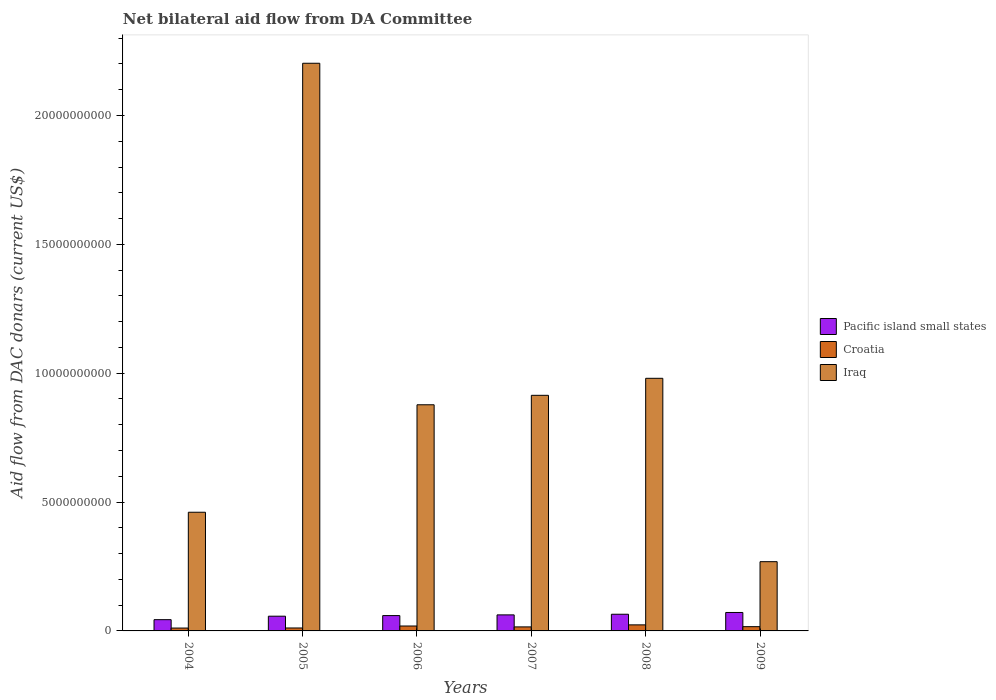How many different coloured bars are there?
Your answer should be compact. 3. How many groups of bars are there?
Give a very brief answer. 6. How many bars are there on the 6th tick from the right?
Offer a very short reply. 3. What is the label of the 4th group of bars from the left?
Offer a terse response. 2007. What is the aid flow in in Pacific island small states in 2005?
Ensure brevity in your answer.  5.71e+08. Across all years, what is the maximum aid flow in in Croatia?
Offer a terse response. 2.35e+08. Across all years, what is the minimum aid flow in in Pacific island small states?
Offer a terse response. 4.37e+08. What is the total aid flow in in Pacific island small states in the graph?
Your answer should be compact. 3.59e+09. What is the difference between the aid flow in in Pacific island small states in 2006 and that in 2007?
Provide a succinct answer. -2.73e+07. What is the difference between the aid flow in in Pacific island small states in 2005 and the aid flow in in Croatia in 2006?
Keep it short and to the point. 3.81e+08. What is the average aid flow in in Croatia per year?
Offer a very short reply. 1.62e+08. In the year 2004, what is the difference between the aid flow in in Iraq and aid flow in in Pacific island small states?
Provide a succinct answer. 4.17e+09. What is the ratio of the aid flow in in Croatia in 2006 to that in 2008?
Keep it short and to the point. 0.81. Is the aid flow in in Croatia in 2004 less than that in 2008?
Provide a short and direct response. Yes. Is the difference between the aid flow in in Iraq in 2004 and 2006 greater than the difference between the aid flow in in Pacific island small states in 2004 and 2006?
Offer a very short reply. No. What is the difference between the highest and the second highest aid flow in in Croatia?
Your response must be concise. 4.46e+07. What is the difference between the highest and the lowest aid flow in in Iraq?
Keep it short and to the point. 1.93e+1. What does the 2nd bar from the left in 2005 represents?
Your answer should be very brief. Croatia. What does the 3rd bar from the right in 2005 represents?
Offer a very short reply. Pacific island small states. Is it the case that in every year, the sum of the aid flow in in Croatia and aid flow in in Iraq is greater than the aid flow in in Pacific island small states?
Offer a terse response. Yes. How many bars are there?
Provide a short and direct response. 18. How many years are there in the graph?
Your response must be concise. 6. Does the graph contain grids?
Your response must be concise. No. Where does the legend appear in the graph?
Provide a succinct answer. Center right. How many legend labels are there?
Give a very brief answer. 3. How are the legend labels stacked?
Ensure brevity in your answer.  Vertical. What is the title of the graph?
Give a very brief answer. Net bilateral aid flow from DA Committee. Does "Tuvalu" appear as one of the legend labels in the graph?
Give a very brief answer. No. What is the label or title of the X-axis?
Make the answer very short. Years. What is the label or title of the Y-axis?
Offer a very short reply. Aid flow from DAC donars (current US$). What is the Aid flow from DAC donars (current US$) of Pacific island small states in 2004?
Provide a succinct answer. 4.37e+08. What is the Aid flow from DAC donars (current US$) in Croatia in 2004?
Your answer should be compact. 1.12e+08. What is the Aid flow from DAC donars (current US$) in Iraq in 2004?
Give a very brief answer. 4.61e+09. What is the Aid flow from DAC donars (current US$) of Pacific island small states in 2005?
Offer a terse response. 5.71e+08. What is the Aid flow from DAC donars (current US$) in Croatia in 2005?
Provide a short and direct response. 1.14e+08. What is the Aid flow from DAC donars (current US$) in Iraq in 2005?
Your answer should be very brief. 2.20e+1. What is the Aid flow from DAC donars (current US$) of Pacific island small states in 2006?
Offer a very short reply. 5.95e+08. What is the Aid flow from DAC donars (current US$) of Croatia in 2006?
Your answer should be compact. 1.90e+08. What is the Aid flow from DAC donars (current US$) in Iraq in 2006?
Make the answer very short. 8.78e+09. What is the Aid flow from DAC donars (current US$) in Pacific island small states in 2007?
Give a very brief answer. 6.22e+08. What is the Aid flow from DAC donars (current US$) in Croatia in 2007?
Give a very brief answer. 1.56e+08. What is the Aid flow from DAC donars (current US$) of Iraq in 2007?
Make the answer very short. 9.14e+09. What is the Aid flow from DAC donars (current US$) in Pacific island small states in 2008?
Offer a terse response. 6.47e+08. What is the Aid flow from DAC donars (current US$) of Croatia in 2008?
Provide a short and direct response. 2.35e+08. What is the Aid flow from DAC donars (current US$) in Iraq in 2008?
Give a very brief answer. 9.80e+09. What is the Aid flow from DAC donars (current US$) in Pacific island small states in 2009?
Ensure brevity in your answer.  7.16e+08. What is the Aid flow from DAC donars (current US$) in Croatia in 2009?
Keep it short and to the point. 1.65e+08. What is the Aid flow from DAC donars (current US$) in Iraq in 2009?
Offer a very short reply. 2.69e+09. Across all years, what is the maximum Aid flow from DAC donars (current US$) of Pacific island small states?
Ensure brevity in your answer.  7.16e+08. Across all years, what is the maximum Aid flow from DAC donars (current US$) in Croatia?
Ensure brevity in your answer.  2.35e+08. Across all years, what is the maximum Aid flow from DAC donars (current US$) in Iraq?
Your answer should be very brief. 2.20e+1. Across all years, what is the minimum Aid flow from DAC donars (current US$) in Pacific island small states?
Your answer should be very brief. 4.37e+08. Across all years, what is the minimum Aid flow from DAC donars (current US$) in Croatia?
Give a very brief answer. 1.12e+08. Across all years, what is the minimum Aid flow from DAC donars (current US$) of Iraq?
Provide a succinct answer. 2.69e+09. What is the total Aid flow from DAC donars (current US$) of Pacific island small states in the graph?
Your answer should be very brief. 3.59e+09. What is the total Aid flow from DAC donars (current US$) in Croatia in the graph?
Your answer should be very brief. 9.72e+08. What is the total Aid flow from DAC donars (current US$) of Iraq in the graph?
Your answer should be very brief. 5.70e+1. What is the difference between the Aid flow from DAC donars (current US$) in Pacific island small states in 2004 and that in 2005?
Your answer should be very brief. -1.34e+08. What is the difference between the Aid flow from DAC donars (current US$) of Croatia in 2004 and that in 2005?
Keep it short and to the point. -2.59e+06. What is the difference between the Aid flow from DAC donars (current US$) in Iraq in 2004 and that in 2005?
Your answer should be very brief. -1.74e+1. What is the difference between the Aid flow from DAC donars (current US$) in Pacific island small states in 2004 and that in 2006?
Your answer should be very brief. -1.58e+08. What is the difference between the Aid flow from DAC donars (current US$) of Croatia in 2004 and that in 2006?
Make the answer very short. -7.90e+07. What is the difference between the Aid flow from DAC donars (current US$) in Iraq in 2004 and that in 2006?
Provide a succinct answer. -4.17e+09. What is the difference between the Aid flow from DAC donars (current US$) in Pacific island small states in 2004 and that in 2007?
Make the answer very short. -1.85e+08. What is the difference between the Aid flow from DAC donars (current US$) in Croatia in 2004 and that in 2007?
Your answer should be very brief. -4.49e+07. What is the difference between the Aid flow from DAC donars (current US$) of Iraq in 2004 and that in 2007?
Your response must be concise. -4.54e+09. What is the difference between the Aid flow from DAC donars (current US$) of Pacific island small states in 2004 and that in 2008?
Your answer should be compact. -2.10e+08. What is the difference between the Aid flow from DAC donars (current US$) of Croatia in 2004 and that in 2008?
Offer a very short reply. -1.24e+08. What is the difference between the Aid flow from DAC donars (current US$) of Iraq in 2004 and that in 2008?
Give a very brief answer. -5.20e+09. What is the difference between the Aid flow from DAC donars (current US$) of Pacific island small states in 2004 and that in 2009?
Your answer should be very brief. -2.79e+08. What is the difference between the Aid flow from DAC donars (current US$) of Croatia in 2004 and that in 2009?
Keep it short and to the point. -5.34e+07. What is the difference between the Aid flow from DAC donars (current US$) in Iraq in 2004 and that in 2009?
Make the answer very short. 1.92e+09. What is the difference between the Aid flow from DAC donars (current US$) of Pacific island small states in 2005 and that in 2006?
Offer a very short reply. -2.35e+07. What is the difference between the Aid flow from DAC donars (current US$) in Croatia in 2005 and that in 2006?
Give a very brief answer. -7.64e+07. What is the difference between the Aid flow from DAC donars (current US$) in Iraq in 2005 and that in 2006?
Keep it short and to the point. 1.33e+1. What is the difference between the Aid flow from DAC donars (current US$) in Pacific island small states in 2005 and that in 2007?
Give a very brief answer. -5.08e+07. What is the difference between the Aid flow from DAC donars (current US$) of Croatia in 2005 and that in 2007?
Provide a short and direct response. -4.23e+07. What is the difference between the Aid flow from DAC donars (current US$) in Iraq in 2005 and that in 2007?
Provide a short and direct response. 1.29e+1. What is the difference between the Aid flow from DAC donars (current US$) in Pacific island small states in 2005 and that in 2008?
Offer a very short reply. -7.57e+07. What is the difference between the Aid flow from DAC donars (current US$) of Croatia in 2005 and that in 2008?
Provide a succinct answer. -1.21e+08. What is the difference between the Aid flow from DAC donars (current US$) of Iraq in 2005 and that in 2008?
Offer a terse response. 1.22e+1. What is the difference between the Aid flow from DAC donars (current US$) of Pacific island small states in 2005 and that in 2009?
Provide a short and direct response. -1.45e+08. What is the difference between the Aid flow from DAC donars (current US$) in Croatia in 2005 and that in 2009?
Give a very brief answer. -5.08e+07. What is the difference between the Aid flow from DAC donars (current US$) in Iraq in 2005 and that in 2009?
Your response must be concise. 1.93e+1. What is the difference between the Aid flow from DAC donars (current US$) of Pacific island small states in 2006 and that in 2007?
Your answer should be very brief. -2.73e+07. What is the difference between the Aid flow from DAC donars (current US$) in Croatia in 2006 and that in 2007?
Your answer should be very brief. 3.41e+07. What is the difference between the Aid flow from DAC donars (current US$) of Iraq in 2006 and that in 2007?
Give a very brief answer. -3.67e+08. What is the difference between the Aid flow from DAC donars (current US$) of Pacific island small states in 2006 and that in 2008?
Keep it short and to the point. -5.22e+07. What is the difference between the Aid flow from DAC donars (current US$) of Croatia in 2006 and that in 2008?
Provide a succinct answer. -4.46e+07. What is the difference between the Aid flow from DAC donars (current US$) of Iraq in 2006 and that in 2008?
Offer a terse response. -1.03e+09. What is the difference between the Aid flow from DAC donars (current US$) of Pacific island small states in 2006 and that in 2009?
Provide a short and direct response. -1.21e+08. What is the difference between the Aid flow from DAC donars (current US$) of Croatia in 2006 and that in 2009?
Keep it short and to the point. 2.56e+07. What is the difference between the Aid flow from DAC donars (current US$) of Iraq in 2006 and that in 2009?
Provide a succinct answer. 6.09e+09. What is the difference between the Aid flow from DAC donars (current US$) in Pacific island small states in 2007 and that in 2008?
Your response must be concise. -2.49e+07. What is the difference between the Aid flow from DAC donars (current US$) in Croatia in 2007 and that in 2008?
Your response must be concise. -7.87e+07. What is the difference between the Aid flow from DAC donars (current US$) in Iraq in 2007 and that in 2008?
Make the answer very short. -6.60e+08. What is the difference between the Aid flow from DAC donars (current US$) in Pacific island small states in 2007 and that in 2009?
Provide a succinct answer. -9.38e+07. What is the difference between the Aid flow from DAC donars (current US$) in Croatia in 2007 and that in 2009?
Offer a terse response. -8.51e+06. What is the difference between the Aid flow from DAC donars (current US$) of Iraq in 2007 and that in 2009?
Ensure brevity in your answer.  6.46e+09. What is the difference between the Aid flow from DAC donars (current US$) in Pacific island small states in 2008 and that in 2009?
Provide a succinct answer. -6.89e+07. What is the difference between the Aid flow from DAC donars (current US$) in Croatia in 2008 and that in 2009?
Provide a succinct answer. 7.02e+07. What is the difference between the Aid flow from DAC donars (current US$) in Iraq in 2008 and that in 2009?
Provide a succinct answer. 7.12e+09. What is the difference between the Aid flow from DAC donars (current US$) in Pacific island small states in 2004 and the Aid flow from DAC donars (current US$) in Croatia in 2005?
Ensure brevity in your answer.  3.23e+08. What is the difference between the Aid flow from DAC donars (current US$) of Pacific island small states in 2004 and the Aid flow from DAC donars (current US$) of Iraq in 2005?
Offer a very short reply. -2.16e+1. What is the difference between the Aid flow from DAC donars (current US$) in Croatia in 2004 and the Aid flow from DAC donars (current US$) in Iraq in 2005?
Provide a succinct answer. -2.19e+1. What is the difference between the Aid flow from DAC donars (current US$) of Pacific island small states in 2004 and the Aid flow from DAC donars (current US$) of Croatia in 2006?
Provide a succinct answer. 2.47e+08. What is the difference between the Aid flow from DAC donars (current US$) in Pacific island small states in 2004 and the Aid flow from DAC donars (current US$) in Iraq in 2006?
Keep it short and to the point. -8.34e+09. What is the difference between the Aid flow from DAC donars (current US$) in Croatia in 2004 and the Aid flow from DAC donars (current US$) in Iraq in 2006?
Ensure brevity in your answer.  -8.66e+09. What is the difference between the Aid flow from DAC donars (current US$) in Pacific island small states in 2004 and the Aid flow from DAC donars (current US$) in Croatia in 2007?
Make the answer very short. 2.81e+08. What is the difference between the Aid flow from DAC donars (current US$) in Pacific island small states in 2004 and the Aid flow from DAC donars (current US$) in Iraq in 2007?
Your answer should be compact. -8.71e+09. What is the difference between the Aid flow from DAC donars (current US$) in Croatia in 2004 and the Aid flow from DAC donars (current US$) in Iraq in 2007?
Your answer should be compact. -9.03e+09. What is the difference between the Aid flow from DAC donars (current US$) of Pacific island small states in 2004 and the Aid flow from DAC donars (current US$) of Croatia in 2008?
Provide a short and direct response. 2.02e+08. What is the difference between the Aid flow from DAC donars (current US$) of Pacific island small states in 2004 and the Aid flow from DAC donars (current US$) of Iraq in 2008?
Your response must be concise. -9.37e+09. What is the difference between the Aid flow from DAC donars (current US$) of Croatia in 2004 and the Aid flow from DAC donars (current US$) of Iraq in 2008?
Ensure brevity in your answer.  -9.69e+09. What is the difference between the Aid flow from DAC donars (current US$) of Pacific island small states in 2004 and the Aid flow from DAC donars (current US$) of Croatia in 2009?
Offer a very short reply. 2.72e+08. What is the difference between the Aid flow from DAC donars (current US$) in Pacific island small states in 2004 and the Aid flow from DAC donars (current US$) in Iraq in 2009?
Keep it short and to the point. -2.25e+09. What is the difference between the Aid flow from DAC donars (current US$) of Croatia in 2004 and the Aid flow from DAC donars (current US$) of Iraq in 2009?
Make the answer very short. -2.58e+09. What is the difference between the Aid flow from DAC donars (current US$) in Pacific island small states in 2005 and the Aid flow from DAC donars (current US$) in Croatia in 2006?
Your answer should be compact. 3.81e+08. What is the difference between the Aid flow from DAC donars (current US$) in Pacific island small states in 2005 and the Aid flow from DAC donars (current US$) in Iraq in 2006?
Offer a terse response. -8.20e+09. What is the difference between the Aid flow from DAC donars (current US$) of Croatia in 2005 and the Aid flow from DAC donars (current US$) of Iraq in 2006?
Your answer should be very brief. -8.66e+09. What is the difference between the Aid flow from DAC donars (current US$) of Pacific island small states in 2005 and the Aid flow from DAC donars (current US$) of Croatia in 2007?
Your answer should be compact. 4.15e+08. What is the difference between the Aid flow from DAC donars (current US$) of Pacific island small states in 2005 and the Aid flow from DAC donars (current US$) of Iraq in 2007?
Keep it short and to the point. -8.57e+09. What is the difference between the Aid flow from DAC donars (current US$) in Croatia in 2005 and the Aid flow from DAC donars (current US$) in Iraq in 2007?
Make the answer very short. -9.03e+09. What is the difference between the Aid flow from DAC donars (current US$) in Pacific island small states in 2005 and the Aid flow from DAC donars (current US$) in Croatia in 2008?
Provide a short and direct response. 3.36e+08. What is the difference between the Aid flow from DAC donars (current US$) of Pacific island small states in 2005 and the Aid flow from DAC donars (current US$) of Iraq in 2008?
Provide a succinct answer. -9.23e+09. What is the difference between the Aid flow from DAC donars (current US$) of Croatia in 2005 and the Aid flow from DAC donars (current US$) of Iraq in 2008?
Ensure brevity in your answer.  -9.69e+09. What is the difference between the Aid flow from DAC donars (current US$) of Pacific island small states in 2005 and the Aid flow from DAC donars (current US$) of Croatia in 2009?
Offer a very short reply. 4.06e+08. What is the difference between the Aid flow from DAC donars (current US$) of Pacific island small states in 2005 and the Aid flow from DAC donars (current US$) of Iraq in 2009?
Offer a terse response. -2.12e+09. What is the difference between the Aid flow from DAC donars (current US$) in Croatia in 2005 and the Aid flow from DAC donars (current US$) in Iraq in 2009?
Provide a succinct answer. -2.57e+09. What is the difference between the Aid flow from DAC donars (current US$) of Pacific island small states in 2006 and the Aid flow from DAC donars (current US$) of Croatia in 2007?
Give a very brief answer. 4.39e+08. What is the difference between the Aid flow from DAC donars (current US$) in Pacific island small states in 2006 and the Aid flow from DAC donars (current US$) in Iraq in 2007?
Make the answer very short. -8.55e+09. What is the difference between the Aid flow from DAC donars (current US$) of Croatia in 2006 and the Aid flow from DAC donars (current US$) of Iraq in 2007?
Give a very brief answer. -8.95e+09. What is the difference between the Aid flow from DAC donars (current US$) in Pacific island small states in 2006 and the Aid flow from DAC donars (current US$) in Croatia in 2008?
Keep it short and to the point. 3.60e+08. What is the difference between the Aid flow from DAC donars (current US$) of Pacific island small states in 2006 and the Aid flow from DAC donars (current US$) of Iraq in 2008?
Give a very brief answer. -9.21e+09. What is the difference between the Aid flow from DAC donars (current US$) in Croatia in 2006 and the Aid flow from DAC donars (current US$) in Iraq in 2008?
Make the answer very short. -9.61e+09. What is the difference between the Aid flow from DAC donars (current US$) in Pacific island small states in 2006 and the Aid flow from DAC donars (current US$) in Croatia in 2009?
Provide a succinct answer. 4.30e+08. What is the difference between the Aid flow from DAC donars (current US$) in Pacific island small states in 2006 and the Aid flow from DAC donars (current US$) in Iraq in 2009?
Make the answer very short. -2.09e+09. What is the difference between the Aid flow from DAC donars (current US$) of Croatia in 2006 and the Aid flow from DAC donars (current US$) of Iraq in 2009?
Your answer should be very brief. -2.50e+09. What is the difference between the Aid flow from DAC donars (current US$) of Pacific island small states in 2007 and the Aid flow from DAC donars (current US$) of Croatia in 2008?
Provide a short and direct response. 3.87e+08. What is the difference between the Aid flow from DAC donars (current US$) in Pacific island small states in 2007 and the Aid flow from DAC donars (current US$) in Iraq in 2008?
Your answer should be compact. -9.18e+09. What is the difference between the Aid flow from DAC donars (current US$) in Croatia in 2007 and the Aid flow from DAC donars (current US$) in Iraq in 2008?
Offer a terse response. -9.65e+09. What is the difference between the Aid flow from DAC donars (current US$) of Pacific island small states in 2007 and the Aid flow from DAC donars (current US$) of Croatia in 2009?
Offer a terse response. 4.57e+08. What is the difference between the Aid flow from DAC donars (current US$) of Pacific island small states in 2007 and the Aid flow from DAC donars (current US$) of Iraq in 2009?
Provide a short and direct response. -2.06e+09. What is the difference between the Aid flow from DAC donars (current US$) of Croatia in 2007 and the Aid flow from DAC donars (current US$) of Iraq in 2009?
Give a very brief answer. -2.53e+09. What is the difference between the Aid flow from DAC donars (current US$) in Pacific island small states in 2008 and the Aid flow from DAC donars (current US$) in Croatia in 2009?
Make the answer very short. 4.82e+08. What is the difference between the Aid flow from DAC donars (current US$) in Pacific island small states in 2008 and the Aid flow from DAC donars (current US$) in Iraq in 2009?
Your response must be concise. -2.04e+09. What is the difference between the Aid flow from DAC donars (current US$) of Croatia in 2008 and the Aid flow from DAC donars (current US$) of Iraq in 2009?
Your answer should be compact. -2.45e+09. What is the average Aid flow from DAC donars (current US$) in Pacific island small states per year?
Provide a succinct answer. 5.98e+08. What is the average Aid flow from DAC donars (current US$) in Croatia per year?
Keep it short and to the point. 1.62e+08. What is the average Aid flow from DAC donars (current US$) in Iraq per year?
Keep it short and to the point. 9.51e+09. In the year 2004, what is the difference between the Aid flow from DAC donars (current US$) of Pacific island small states and Aid flow from DAC donars (current US$) of Croatia?
Give a very brief answer. 3.26e+08. In the year 2004, what is the difference between the Aid flow from DAC donars (current US$) of Pacific island small states and Aid flow from DAC donars (current US$) of Iraq?
Give a very brief answer. -4.17e+09. In the year 2004, what is the difference between the Aid flow from DAC donars (current US$) of Croatia and Aid flow from DAC donars (current US$) of Iraq?
Keep it short and to the point. -4.49e+09. In the year 2005, what is the difference between the Aid flow from DAC donars (current US$) of Pacific island small states and Aid flow from DAC donars (current US$) of Croatia?
Offer a very short reply. 4.57e+08. In the year 2005, what is the difference between the Aid flow from DAC donars (current US$) of Pacific island small states and Aid flow from DAC donars (current US$) of Iraq?
Your response must be concise. -2.15e+1. In the year 2005, what is the difference between the Aid flow from DAC donars (current US$) of Croatia and Aid flow from DAC donars (current US$) of Iraq?
Your response must be concise. -2.19e+1. In the year 2006, what is the difference between the Aid flow from DAC donars (current US$) in Pacific island small states and Aid flow from DAC donars (current US$) in Croatia?
Offer a very short reply. 4.04e+08. In the year 2006, what is the difference between the Aid flow from DAC donars (current US$) of Pacific island small states and Aid flow from DAC donars (current US$) of Iraq?
Your answer should be very brief. -8.18e+09. In the year 2006, what is the difference between the Aid flow from DAC donars (current US$) in Croatia and Aid flow from DAC donars (current US$) in Iraq?
Ensure brevity in your answer.  -8.59e+09. In the year 2007, what is the difference between the Aid flow from DAC donars (current US$) of Pacific island small states and Aid flow from DAC donars (current US$) of Croatia?
Provide a succinct answer. 4.66e+08. In the year 2007, what is the difference between the Aid flow from DAC donars (current US$) in Pacific island small states and Aid flow from DAC donars (current US$) in Iraq?
Your response must be concise. -8.52e+09. In the year 2007, what is the difference between the Aid flow from DAC donars (current US$) in Croatia and Aid flow from DAC donars (current US$) in Iraq?
Your answer should be very brief. -8.99e+09. In the year 2008, what is the difference between the Aid flow from DAC donars (current US$) in Pacific island small states and Aid flow from DAC donars (current US$) in Croatia?
Give a very brief answer. 4.12e+08. In the year 2008, what is the difference between the Aid flow from DAC donars (current US$) of Pacific island small states and Aid flow from DAC donars (current US$) of Iraq?
Your answer should be compact. -9.16e+09. In the year 2008, what is the difference between the Aid flow from DAC donars (current US$) in Croatia and Aid flow from DAC donars (current US$) in Iraq?
Make the answer very short. -9.57e+09. In the year 2009, what is the difference between the Aid flow from DAC donars (current US$) of Pacific island small states and Aid flow from DAC donars (current US$) of Croatia?
Your response must be concise. 5.51e+08. In the year 2009, what is the difference between the Aid flow from DAC donars (current US$) of Pacific island small states and Aid flow from DAC donars (current US$) of Iraq?
Keep it short and to the point. -1.97e+09. In the year 2009, what is the difference between the Aid flow from DAC donars (current US$) in Croatia and Aid flow from DAC donars (current US$) in Iraq?
Your answer should be very brief. -2.52e+09. What is the ratio of the Aid flow from DAC donars (current US$) in Pacific island small states in 2004 to that in 2005?
Make the answer very short. 0.77. What is the ratio of the Aid flow from DAC donars (current US$) of Croatia in 2004 to that in 2005?
Give a very brief answer. 0.98. What is the ratio of the Aid flow from DAC donars (current US$) of Iraq in 2004 to that in 2005?
Offer a terse response. 0.21. What is the ratio of the Aid flow from DAC donars (current US$) in Pacific island small states in 2004 to that in 2006?
Your answer should be compact. 0.73. What is the ratio of the Aid flow from DAC donars (current US$) in Croatia in 2004 to that in 2006?
Offer a terse response. 0.59. What is the ratio of the Aid flow from DAC donars (current US$) of Iraq in 2004 to that in 2006?
Ensure brevity in your answer.  0.52. What is the ratio of the Aid flow from DAC donars (current US$) of Pacific island small states in 2004 to that in 2007?
Your answer should be very brief. 0.7. What is the ratio of the Aid flow from DAC donars (current US$) of Croatia in 2004 to that in 2007?
Offer a terse response. 0.71. What is the ratio of the Aid flow from DAC donars (current US$) in Iraq in 2004 to that in 2007?
Provide a succinct answer. 0.5. What is the ratio of the Aid flow from DAC donars (current US$) in Pacific island small states in 2004 to that in 2008?
Make the answer very short. 0.68. What is the ratio of the Aid flow from DAC donars (current US$) in Croatia in 2004 to that in 2008?
Your answer should be very brief. 0.47. What is the ratio of the Aid flow from DAC donars (current US$) of Iraq in 2004 to that in 2008?
Keep it short and to the point. 0.47. What is the ratio of the Aid flow from DAC donars (current US$) of Pacific island small states in 2004 to that in 2009?
Your answer should be very brief. 0.61. What is the ratio of the Aid flow from DAC donars (current US$) in Croatia in 2004 to that in 2009?
Give a very brief answer. 0.68. What is the ratio of the Aid flow from DAC donars (current US$) of Iraq in 2004 to that in 2009?
Ensure brevity in your answer.  1.71. What is the ratio of the Aid flow from DAC donars (current US$) in Pacific island small states in 2005 to that in 2006?
Give a very brief answer. 0.96. What is the ratio of the Aid flow from DAC donars (current US$) of Croatia in 2005 to that in 2006?
Your answer should be very brief. 0.6. What is the ratio of the Aid flow from DAC donars (current US$) in Iraq in 2005 to that in 2006?
Ensure brevity in your answer.  2.51. What is the ratio of the Aid flow from DAC donars (current US$) of Pacific island small states in 2005 to that in 2007?
Your answer should be very brief. 0.92. What is the ratio of the Aid flow from DAC donars (current US$) of Croatia in 2005 to that in 2007?
Ensure brevity in your answer.  0.73. What is the ratio of the Aid flow from DAC donars (current US$) of Iraq in 2005 to that in 2007?
Provide a short and direct response. 2.41. What is the ratio of the Aid flow from DAC donars (current US$) in Pacific island small states in 2005 to that in 2008?
Provide a succinct answer. 0.88. What is the ratio of the Aid flow from DAC donars (current US$) of Croatia in 2005 to that in 2008?
Provide a succinct answer. 0.49. What is the ratio of the Aid flow from DAC donars (current US$) of Iraq in 2005 to that in 2008?
Offer a very short reply. 2.25. What is the ratio of the Aid flow from DAC donars (current US$) of Pacific island small states in 2005 to that in 2009?
Ensure brevity in your answer.  0.8. What is the ratio of the Aid flow from DAC donars (current US$) of Croatia in 2005 to that in 2009?
Provide a short and direct response. 0.69. What is the ratio of the Aid flow from DAC donars (current US$) in Iraq in 2005 to that in 2009?
Provide a succinct answer. 8.2. What is the ratio of the Aid flow from DAC donars (current US$) of Pacific island small states in 2006 to that in 2007?
Give a very brief answer. 0.96. What is the ratio of the Aid flow from DAC donars (current US$) of Croatia in 2006 to that in 2007?
Provide a short and direct response. 1.22. What is the ratio of the Aid flow from DAC donars (current US$) in Iraq in 2006 to that in 2007?
Make the answer very short. 0.96. What is the ratio of the Aid flow from DAC donars (current US$) of Pacific island small states in 2006 to that in 2008?
Provide a short and direct response. 0.92. What is the ratio of the Aid flow from DAC donars (current US$) of Croatia in 2006 to that in 2008?
Keep it short and to the point. 0.81. What is the ratio of the Aid flow from DAC donars (current US$) in Iraq in 2006 to that in 2008?
Your answer should be compact. 0.9. What is the ratio of the Aid flow from DAC donars (current US$) in Pacific island small states in 2006 to that in 2009?
Make the answer very short. 0.83. What is the ratio of the Aid flow from DAC donars (current US$) of Croatia in 2006 to that in 2009?
Your answer should be very brief. 1.15. What is the ratio of the Aid flow from DAC donars (current US$) in Iraq in 2006 to that in 2009?
Give a very brief answer. 3.27. What is the ratio of the Aid flow from DAC donars (current US$) of Pacific island small states in 2007 to that in 2008?
Your answer should be compact. 0.96. What is the ratio of the Aid flow from DAC donars (current US$) in Croatia in 2007 to that in 2008?
Make the answer very short. 0.67. What is the ratio of the Aid flow from DAC donars (current US$) of Iraq in 2007 to that in 2008?
Your response must be concise. 0.93. What is the ratio of the Aid flow from DAC donars (current US$) in Pacific island small states in 2007 to that in 2009?
Provide a succinct answer. 0.87. What is the ratio of the Aid flow from DAC donars (current US$) in Croatia in 2007 to that in 2009?
Make the answer very short. 0.95. What is the ratio of the Aid flow from DAC donars (current US$) in Iraq in 2007 to that in 2009?
Ensure brevity in your answer.  3.4. What is the ratio of the Aid flow from DAC donars (current US$) of Pacific island small states in 2008 to that in 2009?
Your answer should be very brief. 0.9. What is the ratio of the Aid flow from DAC donars (current US$) of Croatia in 2008 to that in 2009?
Ensure brevity in your answer.  1.43. What is the ratio of the Aid flow from DAC donars (current US$) of Iraq in 2008 to that in 2009?
Your response must be concise. 3.65. What is the difference between the highest and the second highest Aid flow from DAC donars (current US$) in Pacific island small states?
Provide a short and direct response. 6.89e+07. What is the difference between the highest and the second highest Aid flow from DAC donars (current US$) in Croatia?
Offer a terse response. 4.46e+07. What is the difference between the highest and the second highest Aid flow from DAC donars (current US$) in Iraq?
Your response must be concise. 1.22e+1. What is the difference between the highest and the lowest Aid flow from DAC donars (current US$) in Pacific island small states?
Offer a terse response. 2.79e+08. What is the difference between the highest and the lowest Aid flow from DAC donars (current US$) of Croatia?
Offer a terse response. 1.24e+08. What is the difference between the highest and the lowest Aid flow from DAC donars (current US$) of Iraq?
Your answer should be compact. 1.93e+1. 